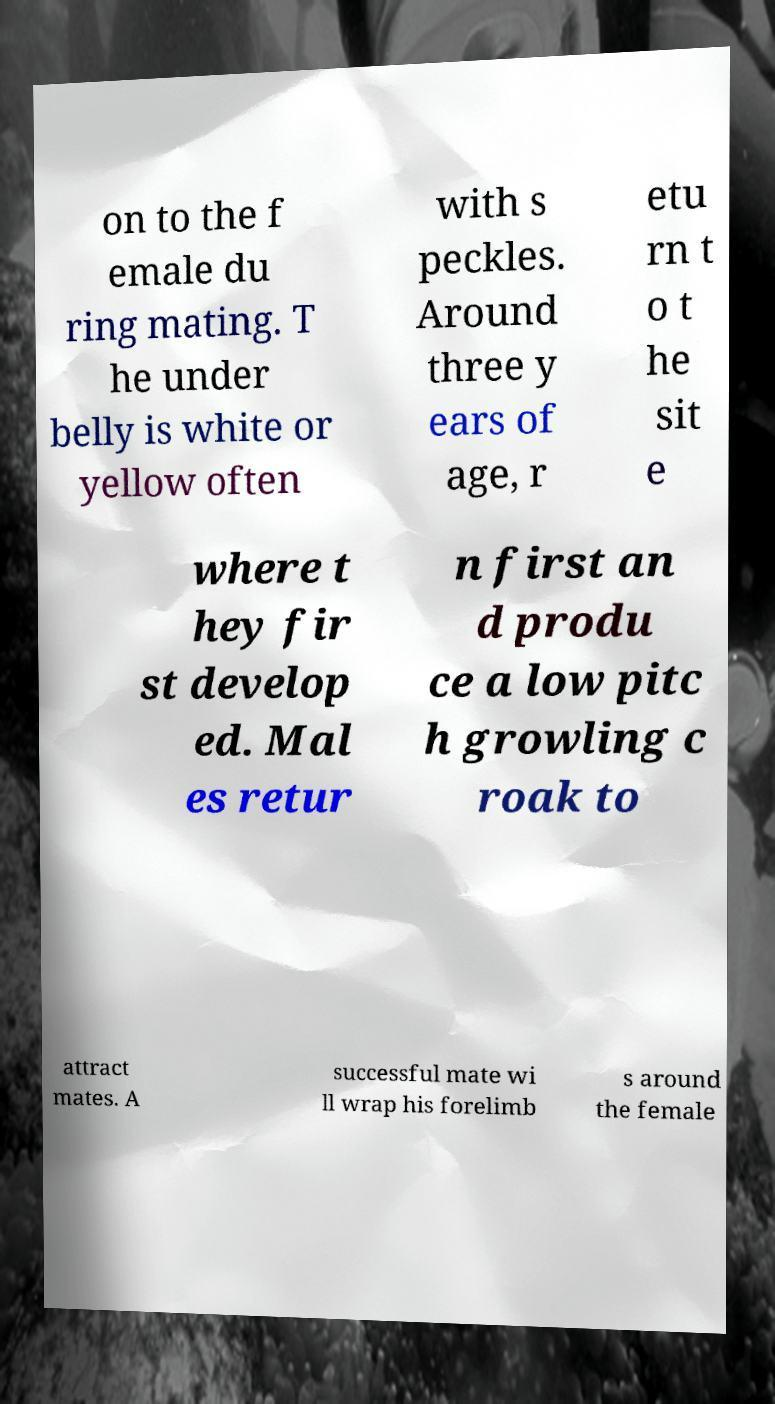I need the written content from this picture converted into text. Can you do that? on to the f emale du ring mating. T he under belly is white or yellow often with s peckles. Around three y ears of age, r etu rn t o t he sit e where t hey fir st develop ed. Mal es retur n first an d produ ce a low pitc h growling c roak to attract mates. A successful mate wi ll wrap his forelimb s around the female 